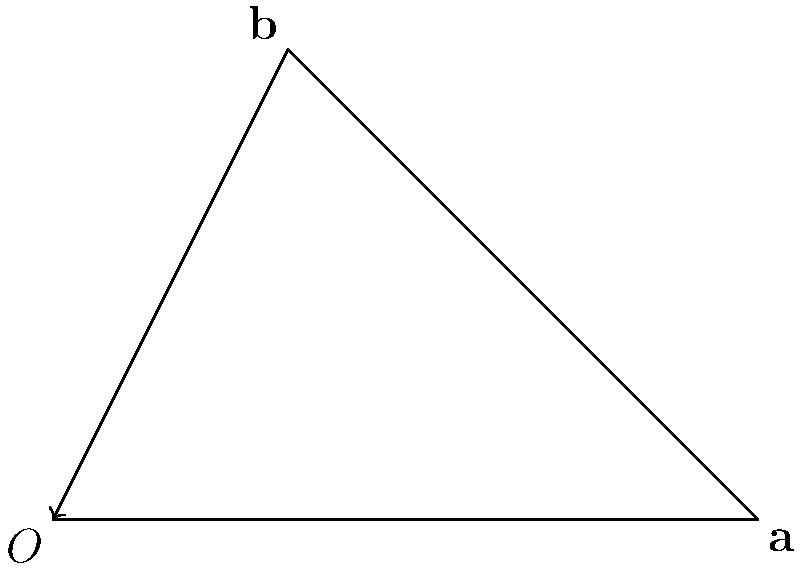Given two vectors $\mathbf{a} = (3, 0)$ and $\mathbf{b} = (1, 2)$, calculate the area of the parallelogram formed by these vectors. To find the area of a parallelogram formed by two vectors, we can use the magnitude of the cross product of these vectors. The steps are as follows:

1) The formula for the area of a parallelogram formed by vectors $\mathbf{a}$ and $\mathbf{b}$ is:

   Area = $|\mathbf{a} \times \mathbf{b}|$

2) For 2D vectors $\mathbf{a} = (a_x, a_y)$ and $\mathbf{b} = (b_x, b_y)$, the cross product is calculated as:

   $|\mathbf{a} \times \mathbf{b}| = |a_x b_y - a_y b_x|$

3) Substituting the given values:
   $\mathbf{a} = (3, 0)$ and $\mathbf{b} = (1, 2)$

4) Calculate:
   $|\mathbf{a} \times \mathbf{b}| = |(3)(2) - (0)(1)|$
                                  $= |6 - 0|$
                                  $= 6$

Therefore, the area of the parallelogram is 6 square units.
Answer: 6 square units 